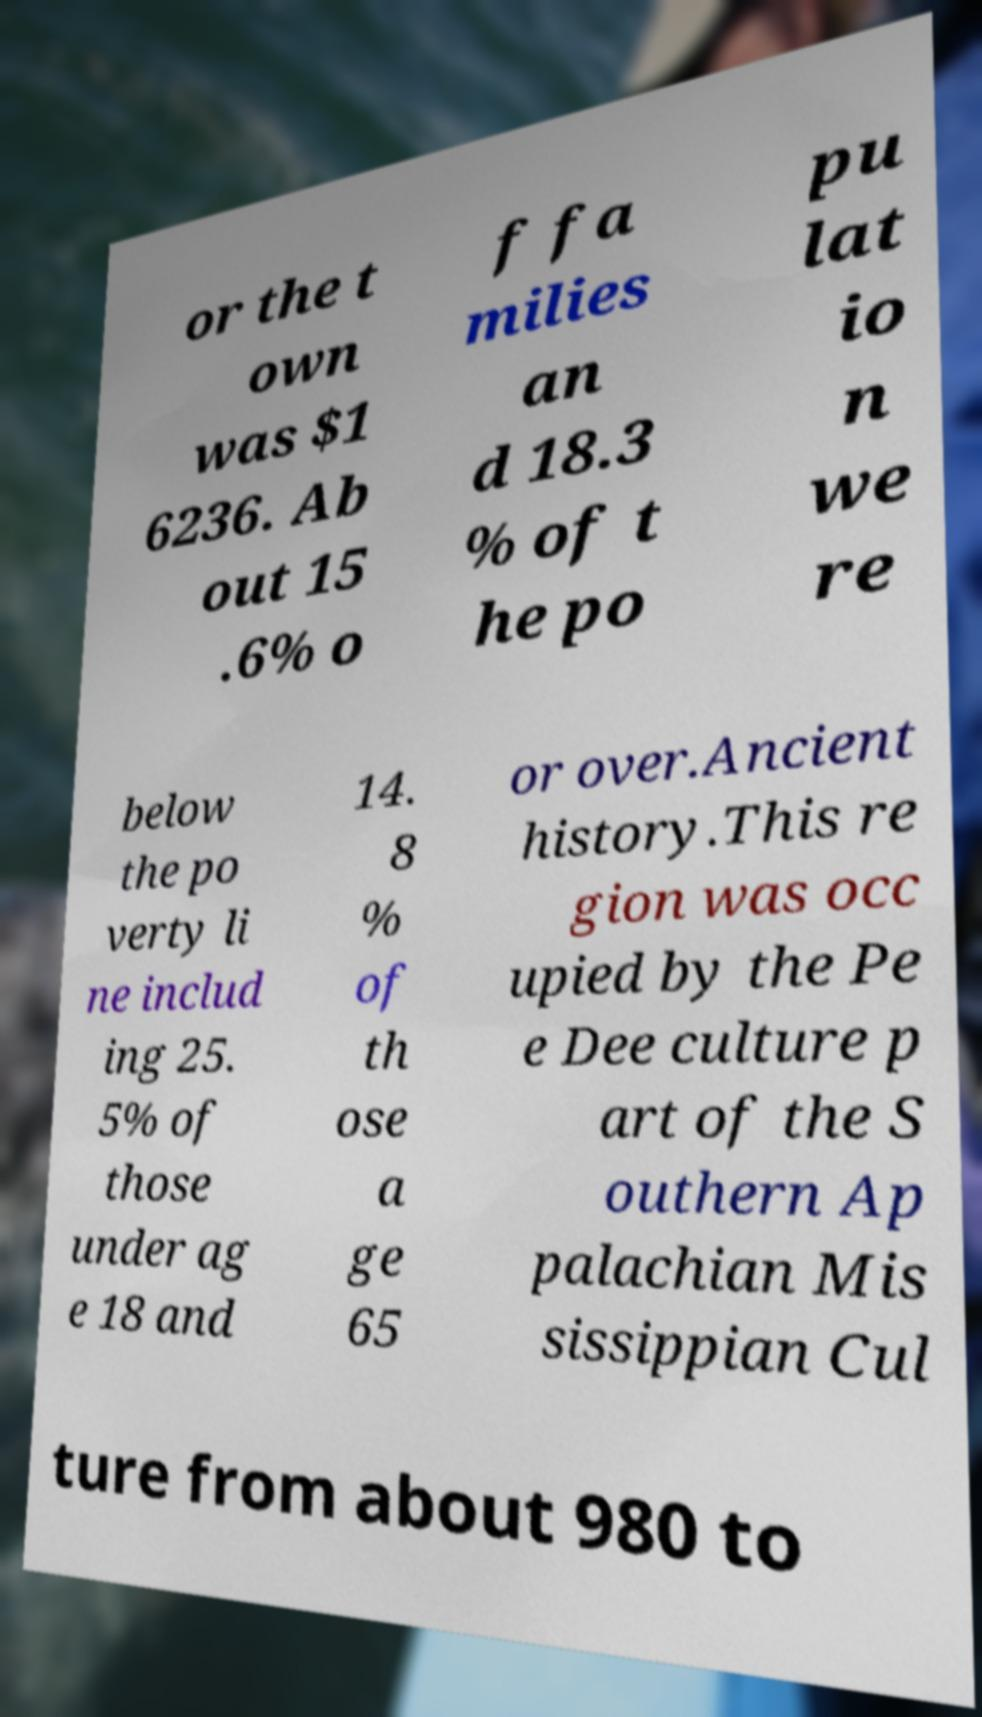There's text embedded in this image that I need extracted. Can you transcribe it verbatim? or the t own was $1 6236. Ab out 15 .6% o f fa milies an d 18.3 % of t he po pu lat io n we re below the po verty li ne includ ing 25. 5% of those under ag e 18 and 14. 8 % of th ose a ge 65 or over.Ancient history.This re gion was occ upied by the Pe e Dee culture p art of the S outhern Ap palachian Mis sissippian Cul ture from about 980 to 